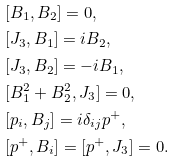<formula> <loc_0><loc_0><loc_500><loc_500>& [ B _ { 1 } , B _ { 2 } ] = 0 , \\ & [ J _ { 3 } , B _ { 1 } ] = i B _ { 2 } , \\ & [ J _ { 3 } , B _ { 2 } ] = - i B _ { 1 } , \\ & [ B ^ { 2 } _ { 1 } + B ^ { 2 } _ { 2 } , J _ { 3 } ] = 0 , \\ & [ p _ { i } , B _ { j } ] = i \delta _ { i j } p ^ { + } , \\ & [ p ^ { + } , B _ { i } ] = [ p ^ { + } , J _ { 3 } ] = 0 .</formula> 